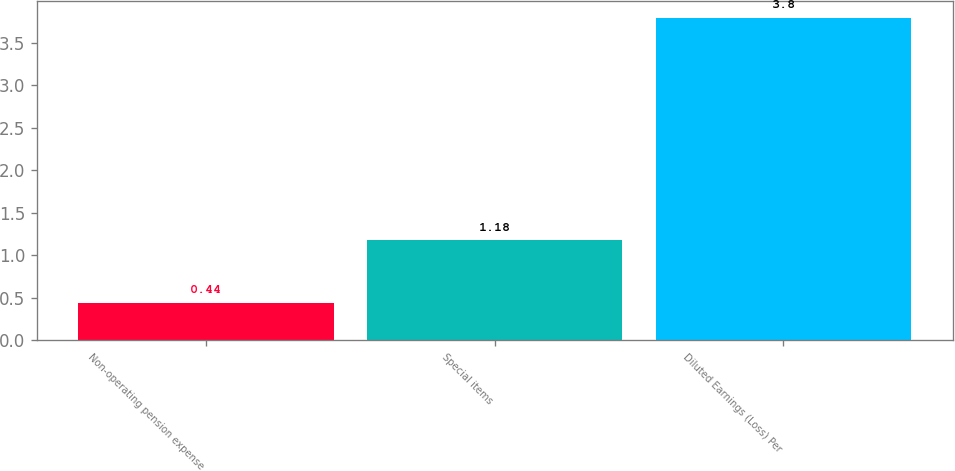Convert chart to OTSL. <chart><loc_0><loc_0><loc_500><loc_500><bar_chart><fcel>Non-operating pension expense<fcel>Special items<fcel>Diluted Earnings (Loss) Per<nl><fcel>0.44<fcel>1.18<fcel>3.8<nl></chart> 